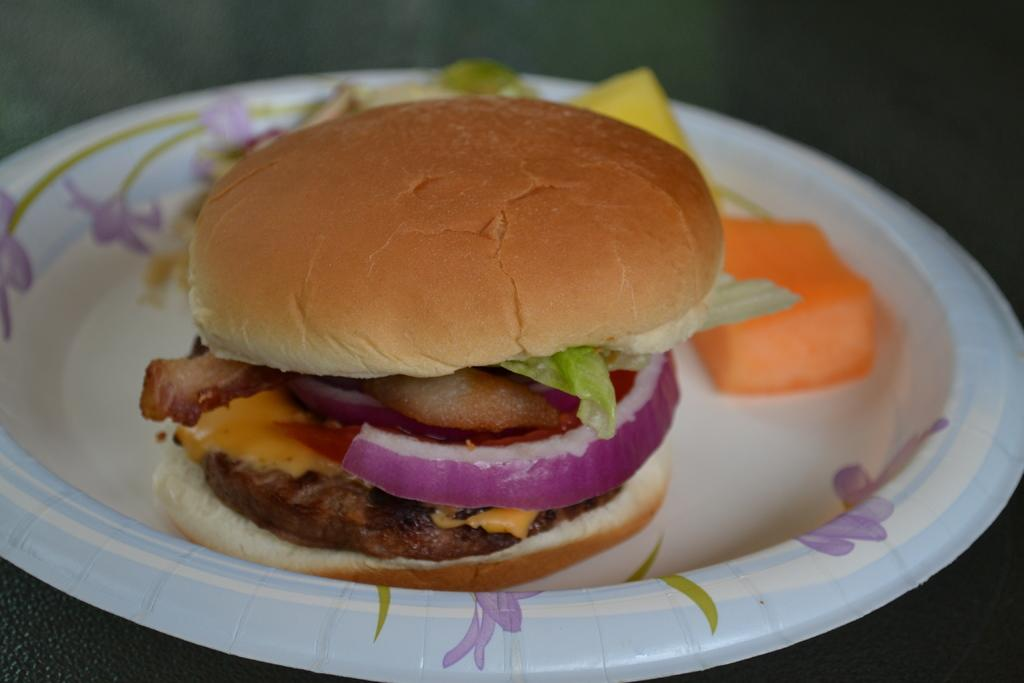What type of food is the main subject of the image? There is a burger in the image. What else is present on the plate in the image? There is food in a plate in the image. Can you describe the background of the image? The background of the image is dark. What type of muscle can be seen flexing in the image? There is no muscle present in the image; it features a burger and food on a plate. How many houses are visible in the image? There are no houses visible in the image; the background is dark. 